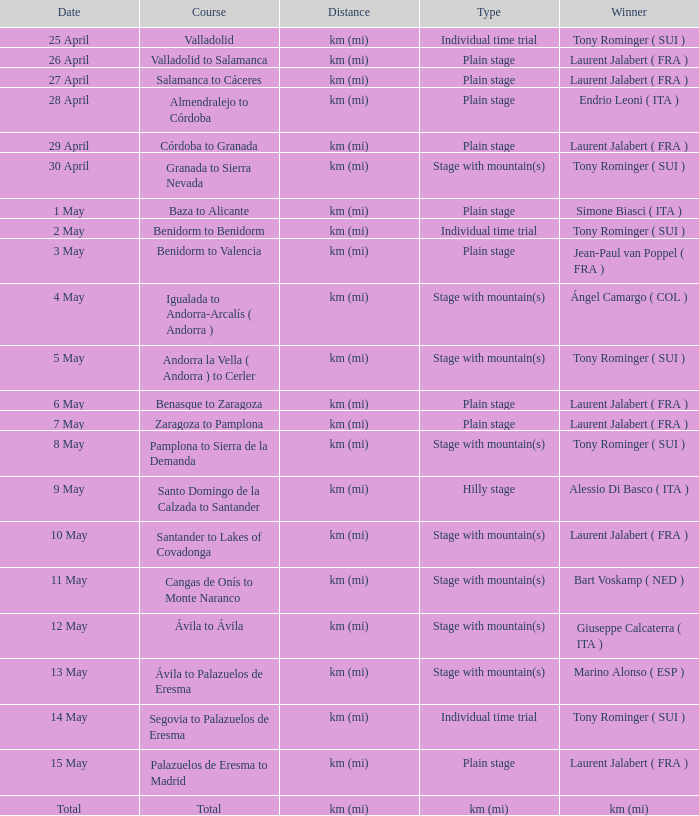What was the occasion with a conqueror of km (mi)? Total. 